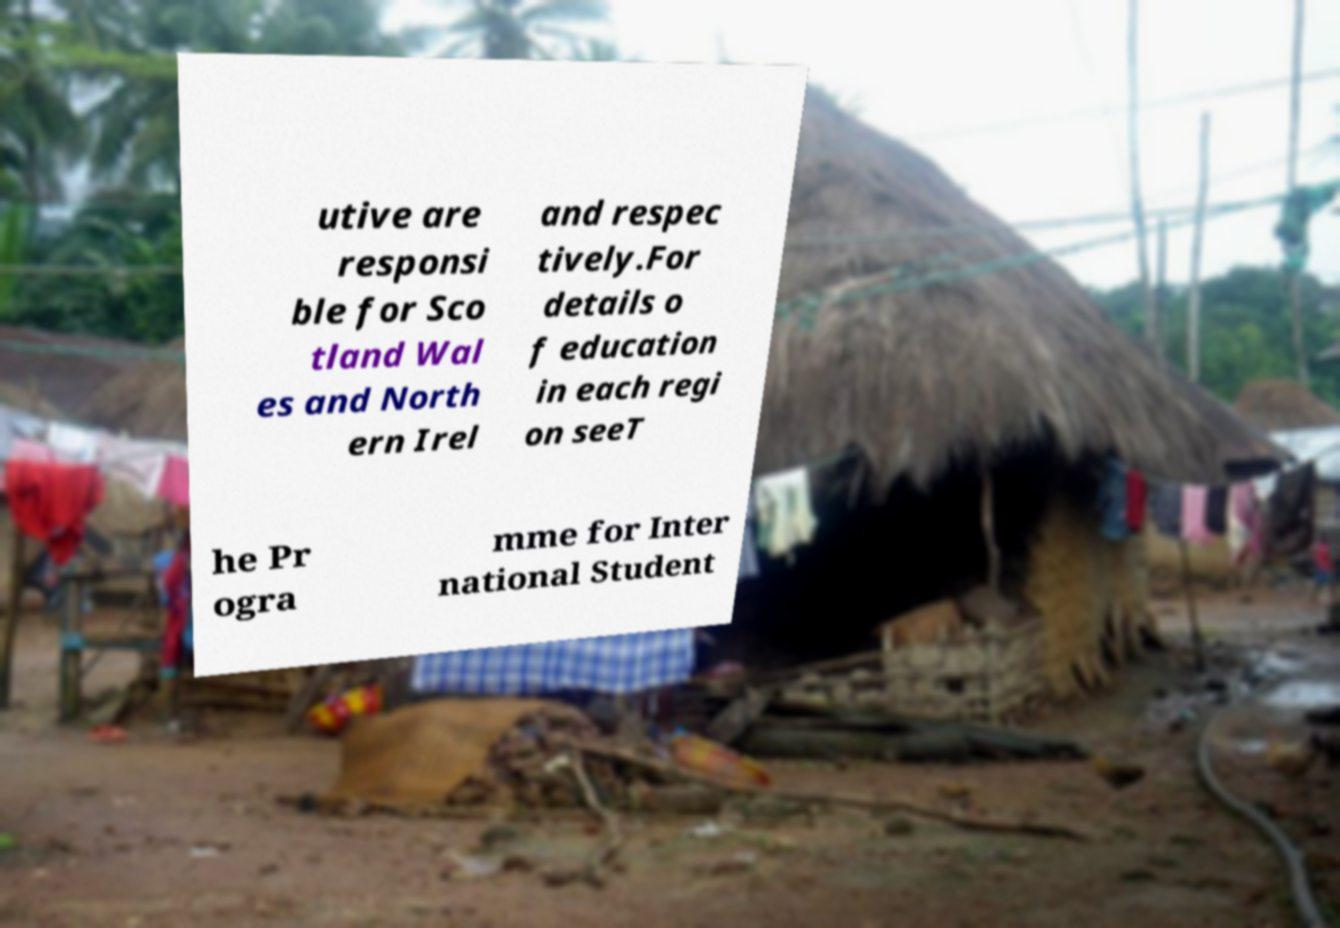Could you extract and type out the text from this image? utive are responsi ble for Sco tland Wal es and North ern Irel and respec tively.For details o f education in each regi on seeT he Pr ogra mme for Inter national Student 